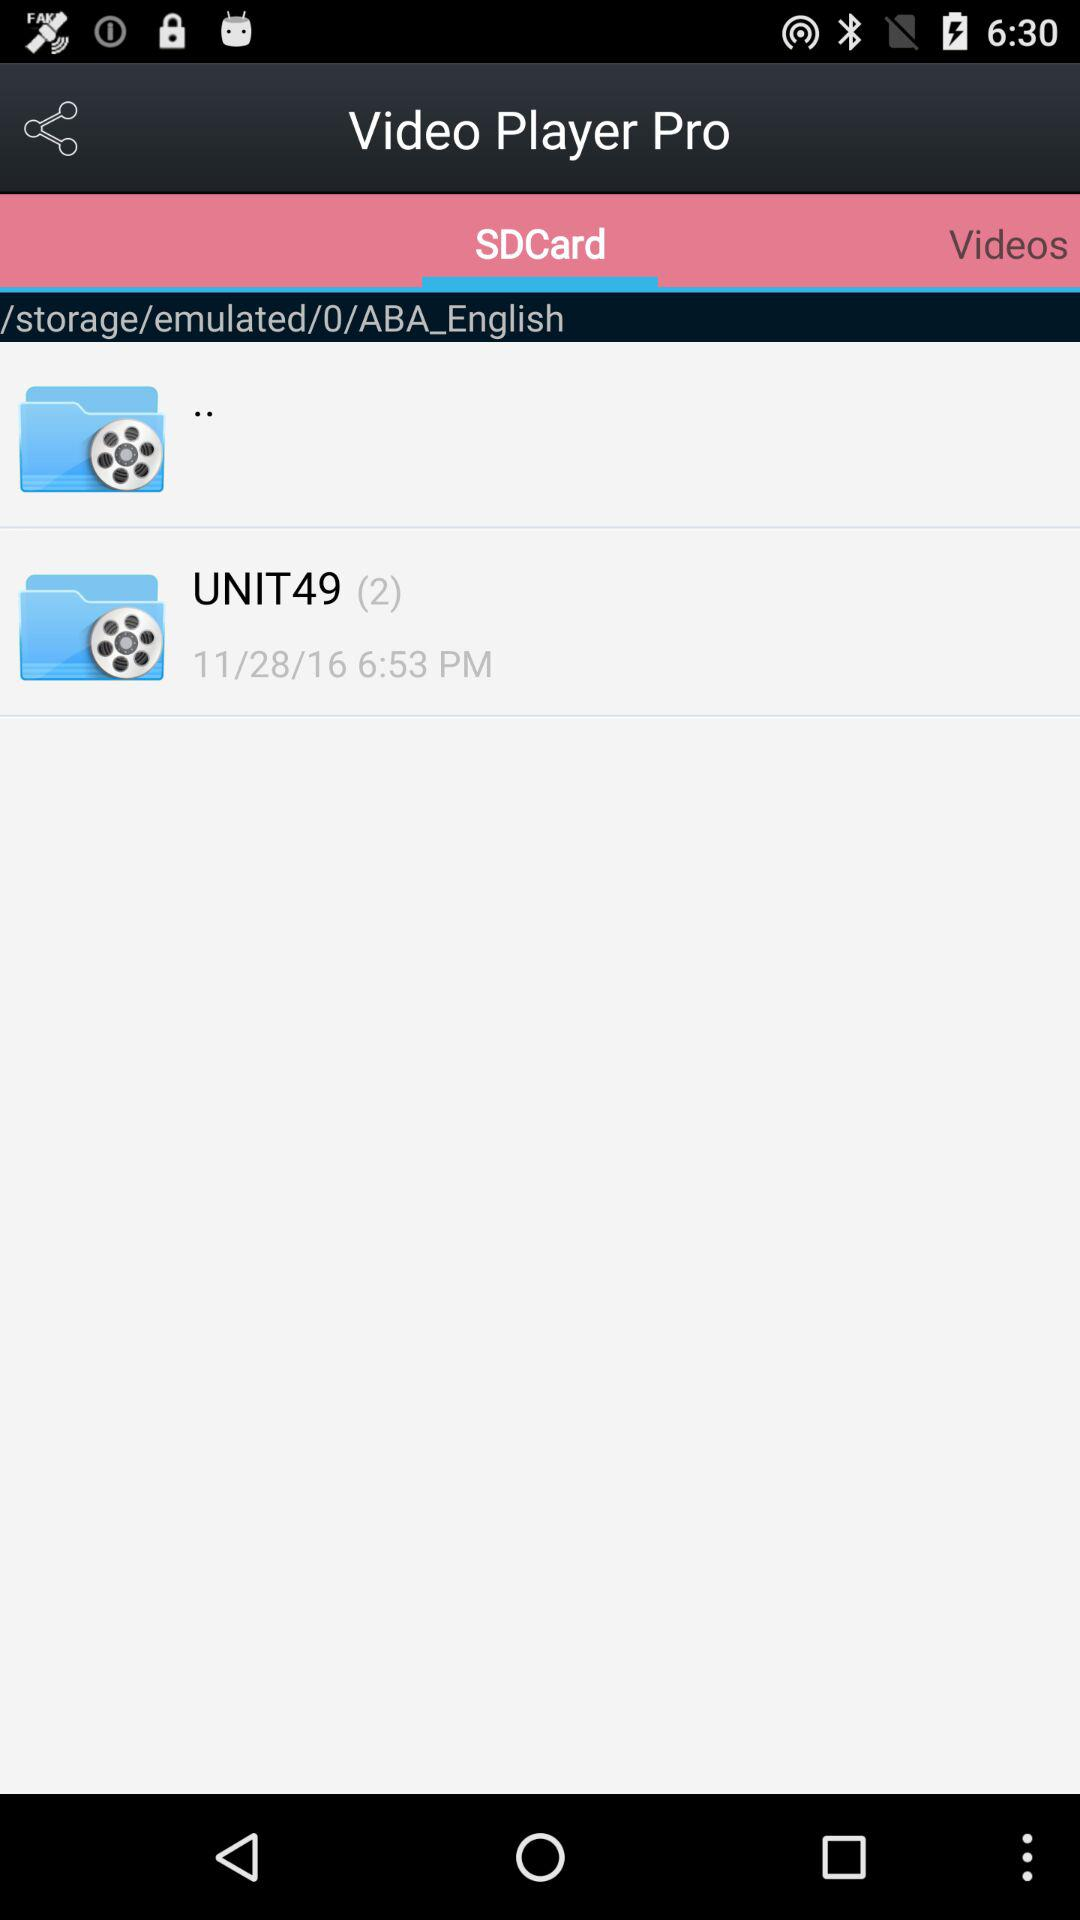What tab is selected? The selected tab is "SDCard". 